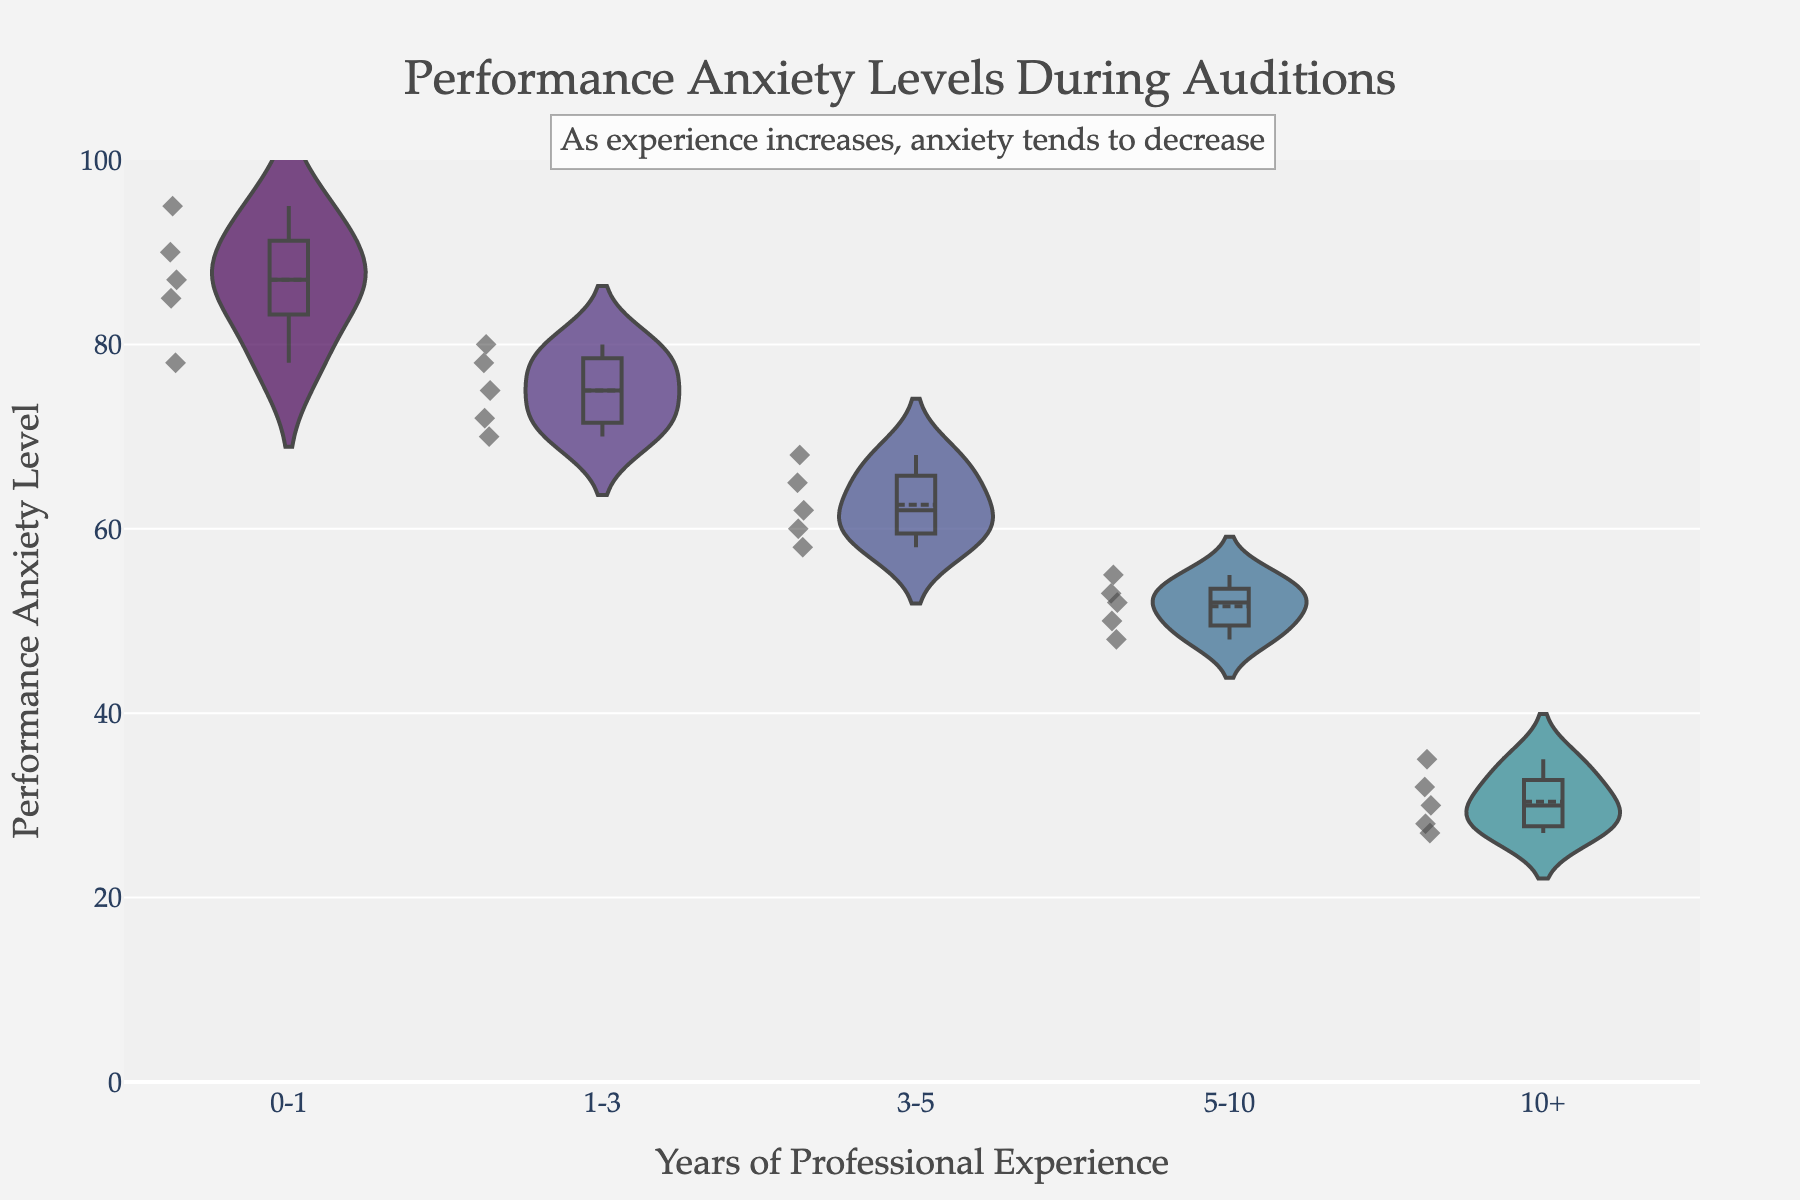what is the y-axis title? The y-axis title is displayed along the vertical axis, and it provides information about the data being measured. In this chart, it indicates what the values on the y-axis represent.
Answer: Performance Anxiety Level What are the categories displayed on the x-axis? The categories on the x-axis represent the different groups of professional experience. You can see the distinct categories labeled along the horizontal axis.
Answer: 0-1, 1-3, 3-5, 5-10, 10+ Which group has the highest maximum anxiety level recorded? To find the group with the highest maximum anxiety level, look at the violin plot and find the group with the violin that extends the furthest upwards.
Answer: 0-1 Which group shows the lowest minimum anxiety level? Look at the violin plots and find the group with the lowest point among the plotted anxiety levels. The minimum value is the lowest point in that group.
Answer: 10+ What is the range of performance anxiety levels for the 1-3 years group? The range is calculated by finding the difference between the maximum and minimum values within the 1-3 years group. Observe the ends of the violin plot for the appropriate range.
Answer: 70 to 80 How does the spread of anxiety levels in the 5-10 years group compare to the spread in the 0-1 years group? Compare the width and extent of the violin plots for these two groups. The spread can be understood by how wide or narrow the plots appear and the range of values they cover.
Answer: The 0-1 years group has a wider spread, while the 5-10 years group is narrower What's the approximate median anxiety level for the 3-5 years group? Look at the white line in the middle of the violin plot for the 3-5 years group, which represents the median or the middle value of the dataset.
Answer: Approximately 62 Which group shows the most variability in performance anxiety levels? Variability can be seen by examining how wide and filled out the violins are. The wider and more filled a violin is, the more variability there is in that group's anxiety levels.
Answer: 0-1 What general trend do you observe about performance anxiety levels as professional experience increases? Identify the overall pattern by looking at the changes in the central values and spread across different groups from less experienced to more experienced.
Answer: Anxiety levels decrease with more experience 